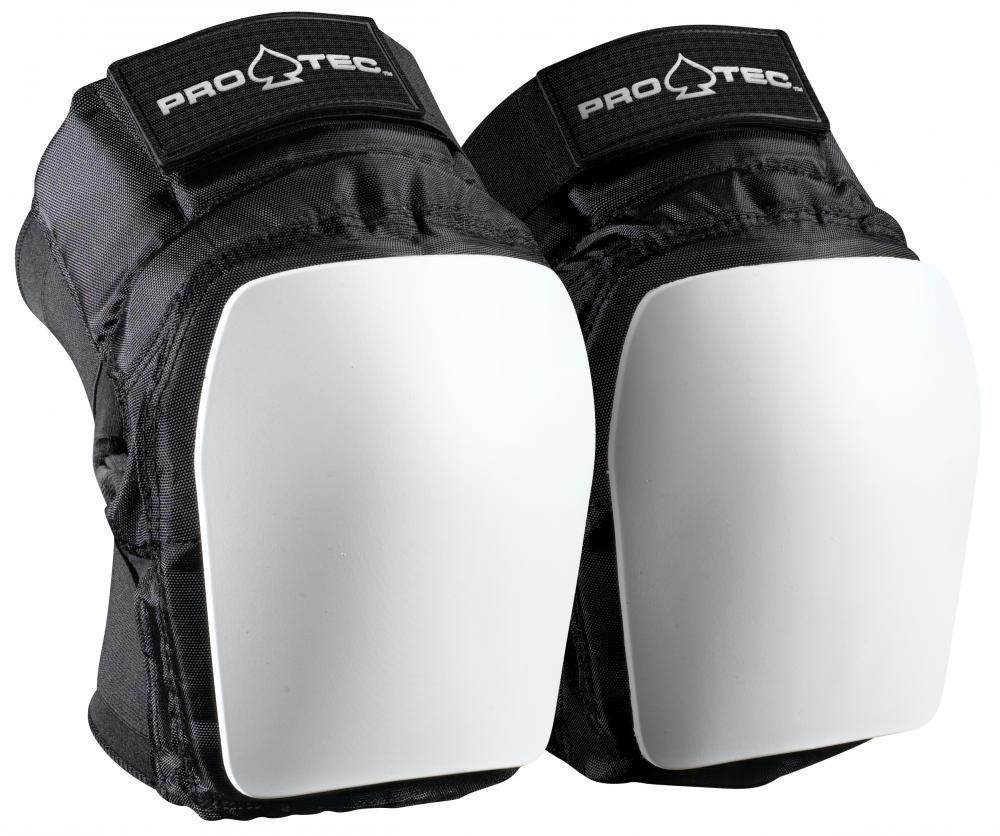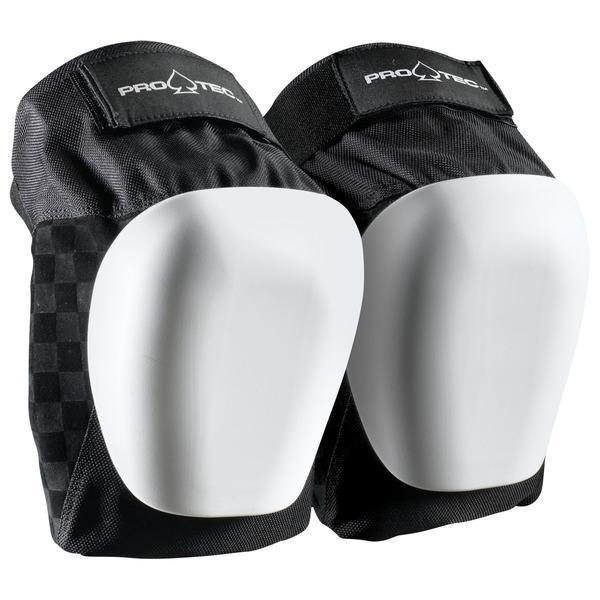The first image is the image on the left, the second image is the image on the right. Assess this claim about the two images: "Both images contain a pair of all black knee pads". Correct or not? Answer yes or no. No. 